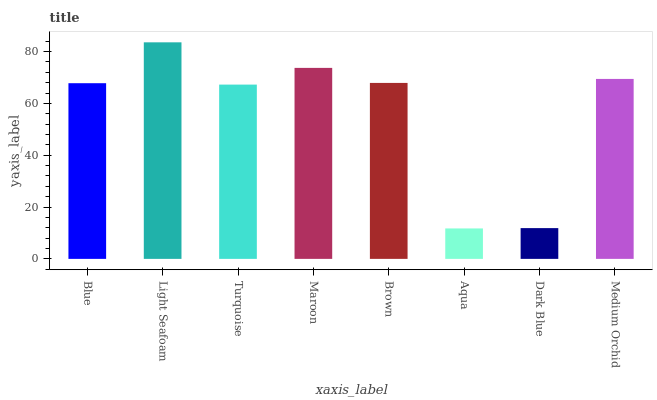Is Aqua the minimum?
Answer yes or no. Yes. Is Light Seafoam the maximum?
Answer yes or no. Yes. Is Turquoise the minimum?
Answer yes or no. No. Is Turquoise the maximum?
Answer yes or no. No. Is Light Seafoam greater than Turquoise?
Answer yes or no. Yes. Is Turquoise less than Light Seafoam?
Answer yes or no. Yes. Is Turquoise greater than Light Seafoam?
Answer yes or no. No. Is Light Seafoam less than Turquoise?
Answer yes or no. No. Is Brown the high median?
Answer yes or no. Yes. Is Blue the low median?
Answer yes or no. Yes. Is Maroon the high median?
Answer yes or no. No. Is Dark Blue the low median?
Answer yes or no. No. 